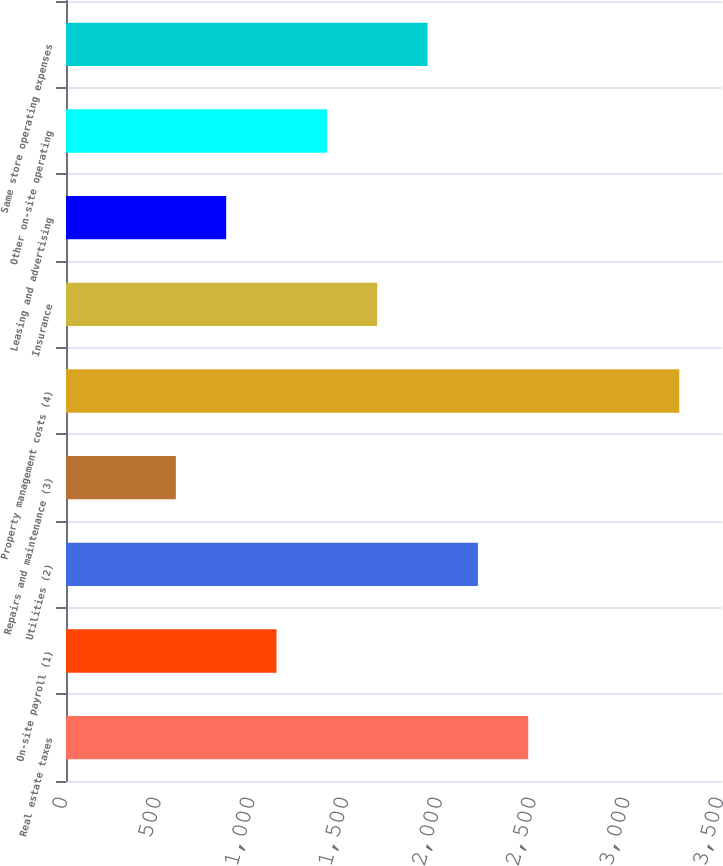<chart> <loc_0><loc_0><loc_500><loc_500><bar_chart><fcel>Real estate taxes<fcel>On-site payroll (1)<fcel>Utilities (2)<fcel>Repairs and maintenance (3)<fcel>Property management costs (4)<fcel>Insurance<fcel>Leasing and advertising<fcel>Other on-site operating<fcel>Same store operating expenses<nl><fcel>2466.2<fcel>1123.2<fcel>2197.6<fcel>586<fcel>3272<fcel>1660.4<fcel>854.6<fcel>1391.8<fcel>1929<nl></chart> 